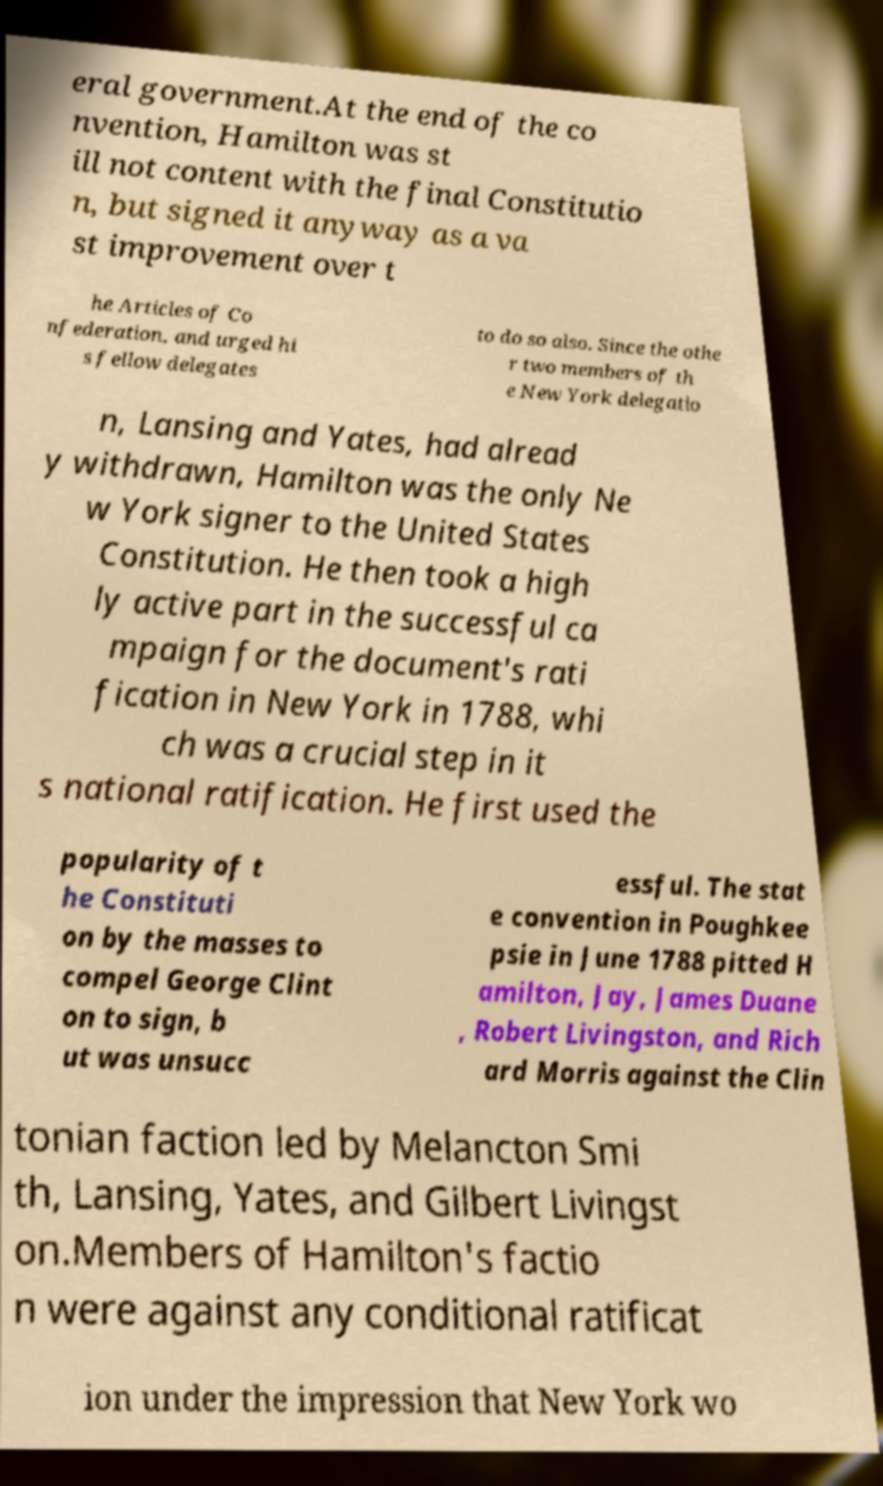Could you assist in decoding the text presented in this image and type it out clearly? eral government.At the end of the co nvention, Hamilton was st ill not content with the final Constitutio n, but signed it anyway as a va st improvement over t he Articles of Co nfederation, and urged hi s fellow delegates to do so also. Since the othe r two members of th e New York delegatio n, Lansing and Yates, had alread y withdrawn, Hamilton was the only Ne w York signer to the United States Constitution. He then took a high ly active part in the successful ca mpaign for the document's rati fication in New York in 1788, whi ch was a crucial step in it s national ratification. He first used the popularity of t he Constituti on by the masses to compel George Clint on to sign, b ut was unsucc essful. The stat e convention in Poughkee psie in June 1788 pitted H amilton, Jay, James Duane , Robert Livingston, and Rich ard Morris against the Clin tonian faction led by Melancton Smi th, Lansing, Yates, and Gilbert Livingst on.Members of Hamilton's factio n were against any conditional ratificat ion under the impression that New York wo 